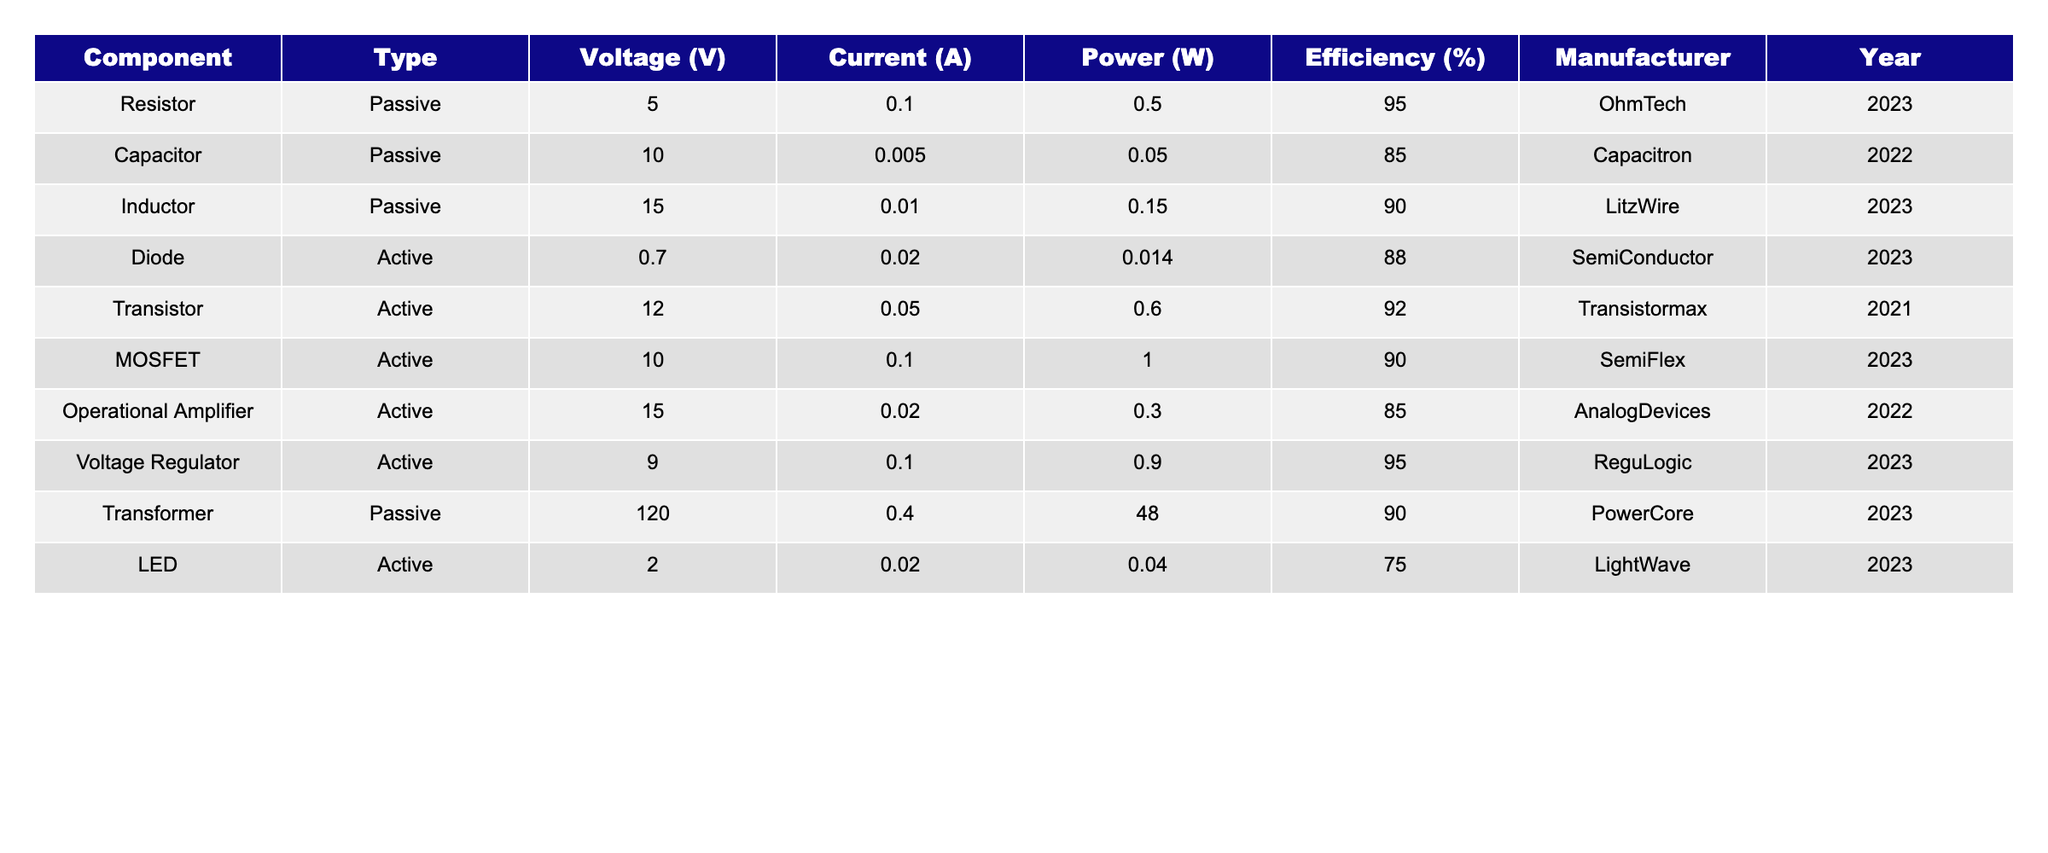What is the efficiency of the Voltage Regulator? The table shows that the Voltage Regulator has an efficiency of 95%.
Answer: 95% Which component has the highest power rating? By examining the Power column, the Transformer has the highest power rating of 48 W.
Answer: 48 W Is the efficiency of the Capacitor above 80%? The Capacitor's efficiency is listed as 85%, which is indeed above 80%.
Answer: Yes What is the total power consumed by the active components? The total power for active components is calculated as follows: 0.014 (Diode) + 0.6 (Transistor) + 1 (MOSFET) + 0.3 (Operational Amplifier) + 0.9 (Voltage Regulator) + 0.04 (LED) = 2.854 W.
Answer: 2.854 W How many manufacturers are listed for the active components? The table includes Transistormax, SemiFlex, AnalogDevices, ReguLogic, and LightWave, totaling 5 different manufacturers for active components.
Answer: 5 Which component has the lowest efficiency and what is that efficiency? The LED has the lowest efficiency at 75%.
Answer: 75% What is the average efficiency of all components in the table? The average efficiency is calculated by summing all efficiencies (95 + 85 + 90 + 88 + 92 + 90 + 85 + 95 + 90 + 75) = 900 and dividing by the number of components, which is 10. So, 900/10 = 90%.
Answer: 90% Does any passive component have an efficiency of 95%? Yes, both the Resistor and the Voltage Regulator, classified as passive and active respectively, have efficiencies of 95%.
Answer: Yes What is the difference in power between the highest and lowest power components? The highest power component is the Transformer with 48 W and the lowest is the Diode with 0.014 W. The difference is 48 - 0.014 = 47.986 W.
Answer: 47.986 W Which type of component appears most frequently in the table? There are 4 active components (Diode, Transistor, MOSFET, Operational Amplifier, Voltage Regulator, LED) and 6 passive components (Resistor, Capacitor, Inductor, Transformer), but considering 6, passive components are the most frequent.
Answer: Passive components 